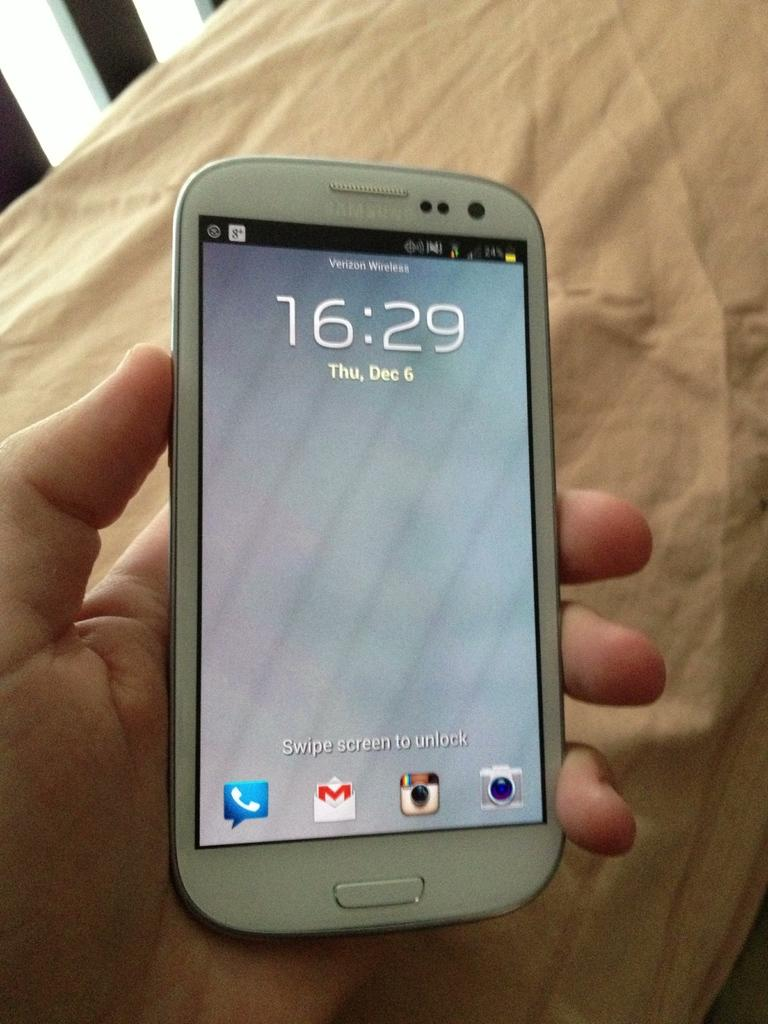Provide a one-sentence caption for the provided image. A white Samsung phone with Verizon Wireless as the carrier and the time showing as 16:29. 